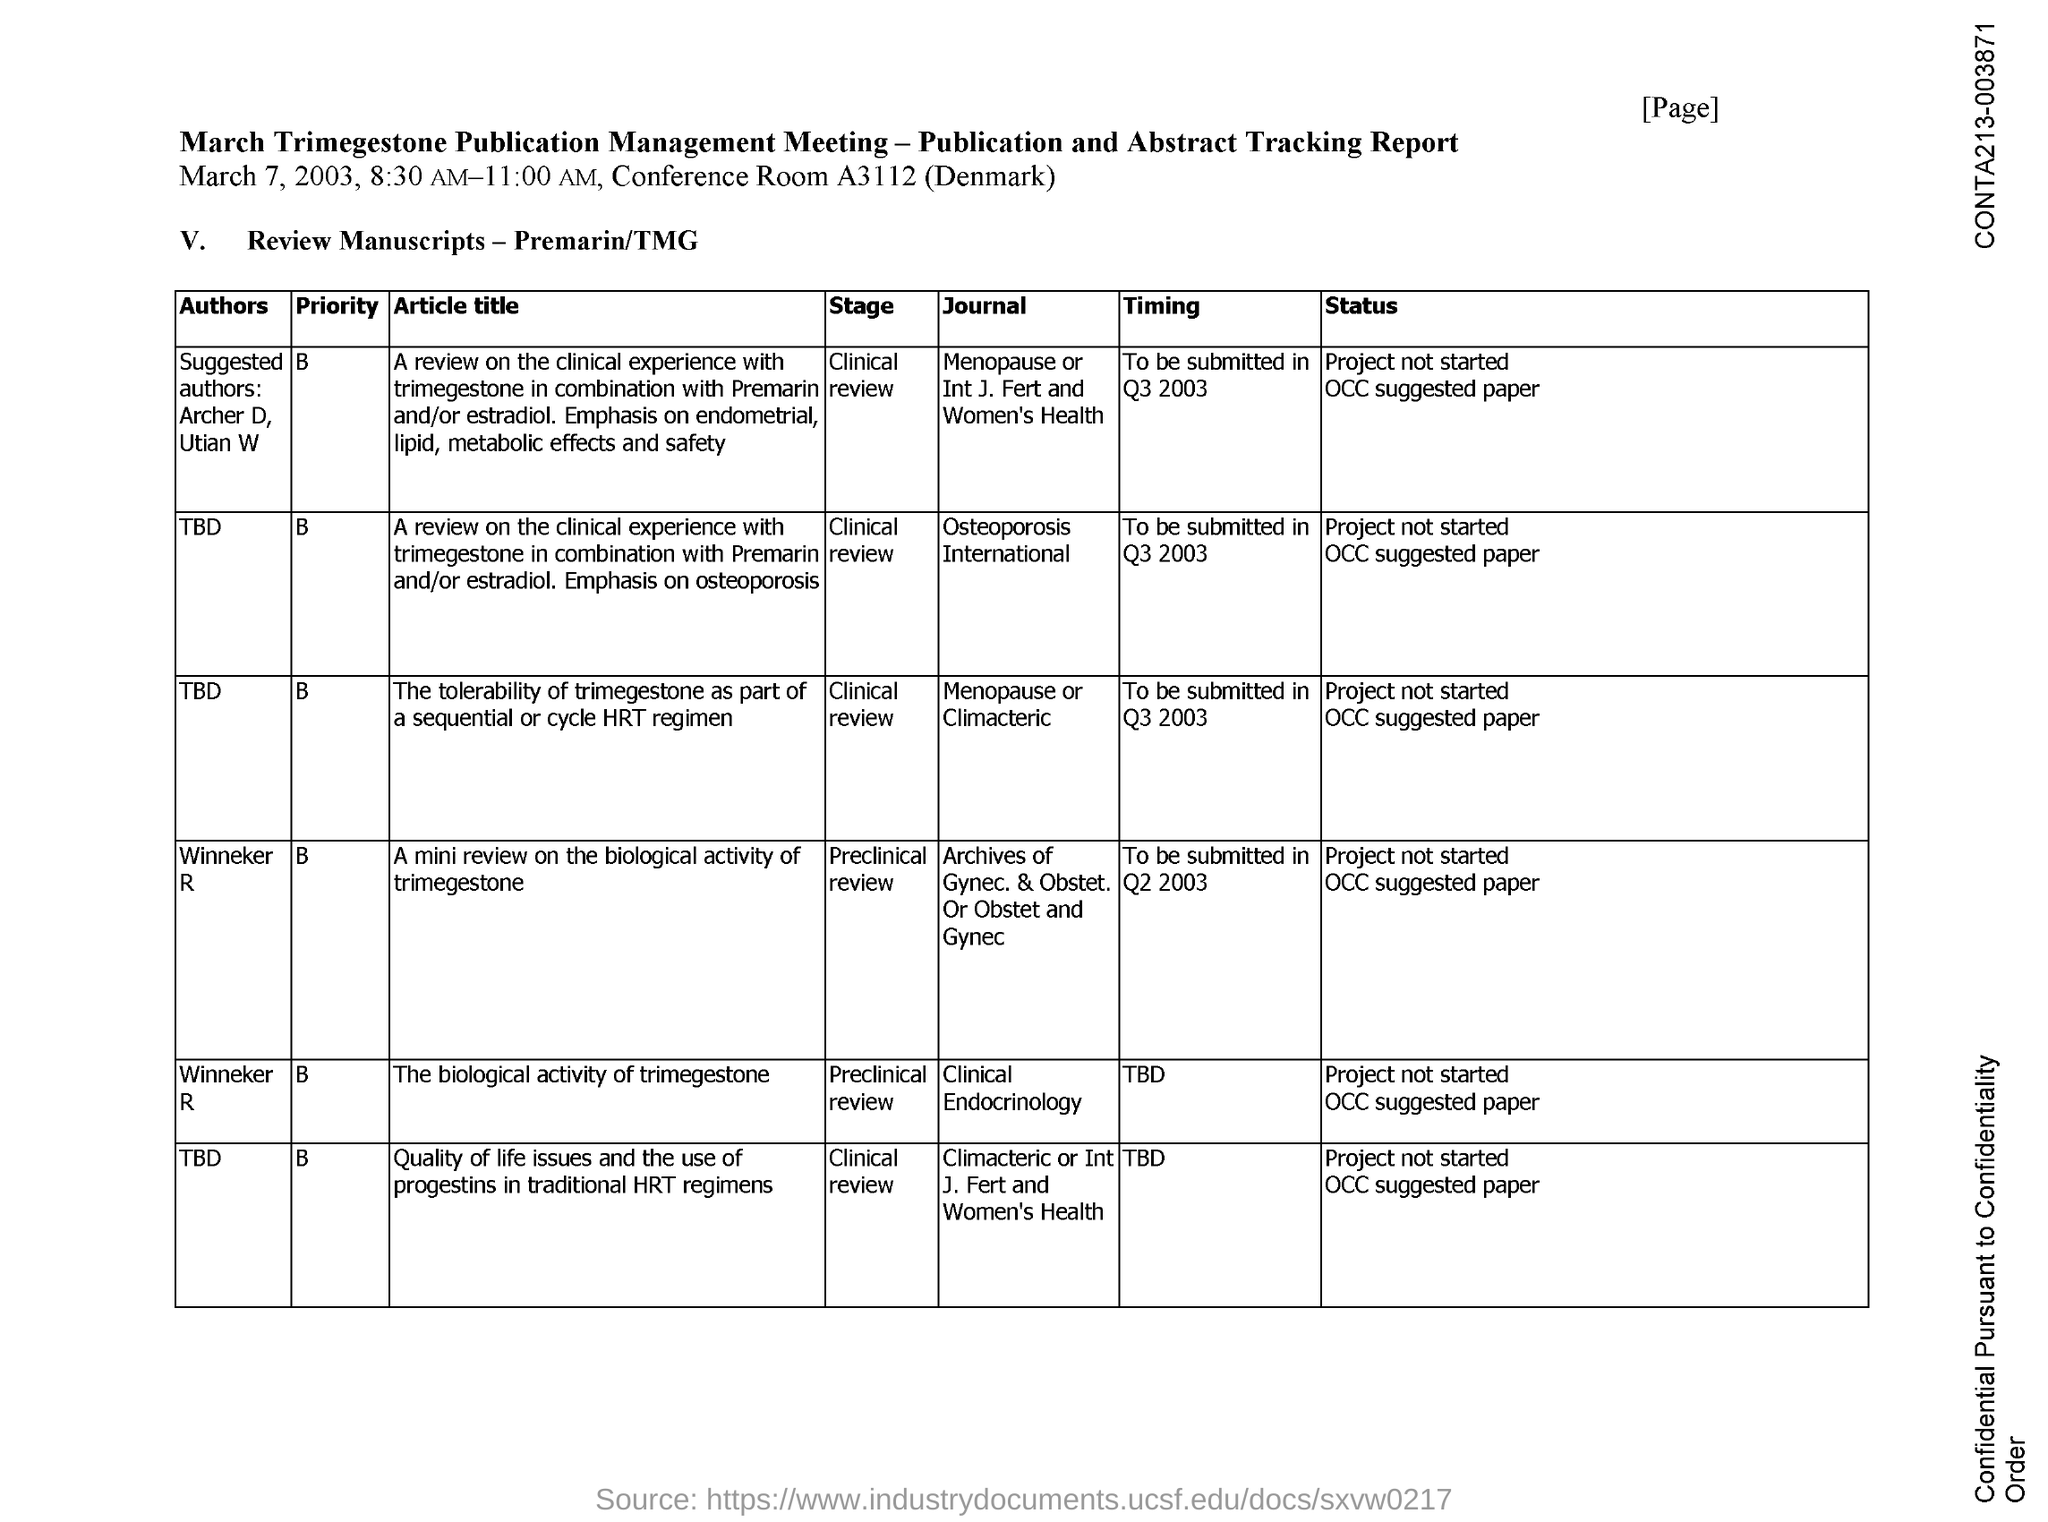What is the date mentioned ?
Your answer should be very brief. March 7, 2003. What is the conference room no ?
Keep it short and to the point. A3112. In which country conference is taking place ?
Offer a very short reply. Denmark. 